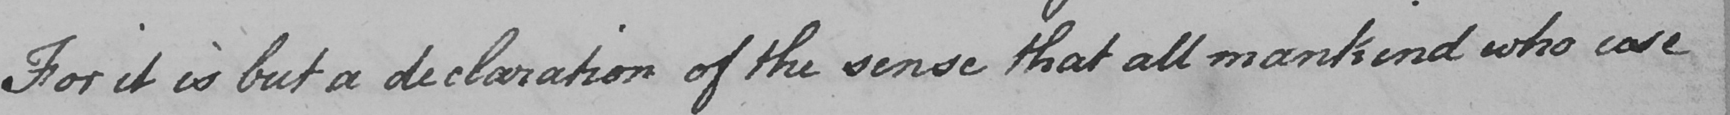What is written in this line of handwriting? For it is but a declaration of the sense that all mankind who care 